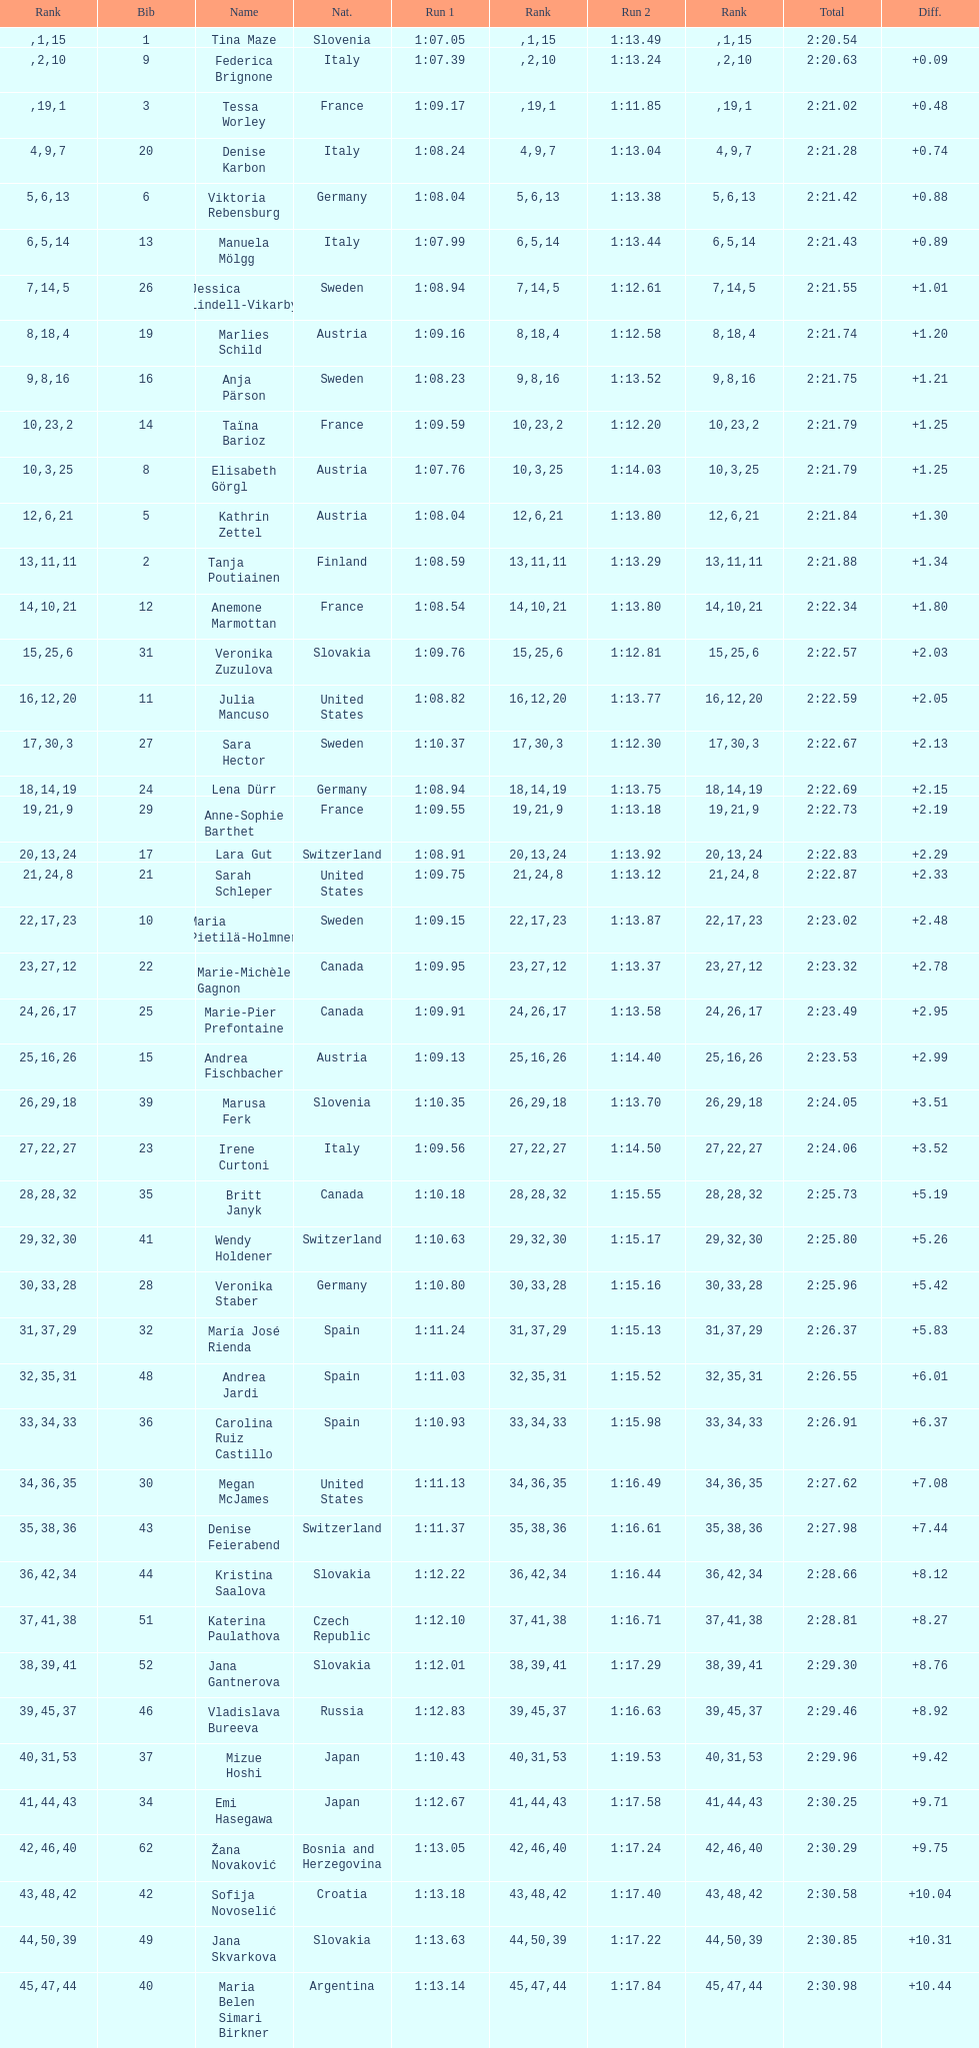Which country is positioned last in the ranking? Czech Republic. Could you help me parse every detail presented in this table? {'header': ['Rank', 'Bib', 'Name', 'Nat.', 'Run 1', 'Rank', 'Run 2', 'Rank', 'Total', 'Diff.'], 'rows': [['', '1', 'Tina Maze', 'Slovenia', '1:07.05', '1', '1:13.49', '15', '2:20.54', ''], ['', '9', 'Federica Brignone', 'Italy', '1:07.39', '2', '1:13.24', '10', '2:20.63', '+0.09'], ['', '3', 'Tessa Worley', 'France', '1:09.17', '19', '1:11.85', '1', '2:21.02', '+0.48'], ['4', '20', 'Denise Karbon', 'Italy', '1:08.24', '9', '1:13.04', '7', '2:21.28', '+0.74'], ['5', '6', 'Viktoria Rebensburg', 'Germany', '1:08.04', '6', '1:13.38', '13', '2:21.42', '+0.88'], ['6', '13', 'Manuela Mölgg', 'Italy', '1:07.99', '5', '1:13.44', '14', '2:21.43', '+0.89'], ['7', '26', 'Jessica Lindell-Vikarby', 'Sweden', '1:08.94', '14', '1:12.61', '5', '2:21.55', '+1.01'], ['8', '19', 'Marlies Schild', 'Austria', '1:09.16', '18', '1:12.58', '4', '2:21.74', '+1.20'], ['9', '16', 'Anja Pärson', 'Sweden', '1:08.23', '8', '1:13.52', '16', '2:21.75', '+1.21'], ['10', '14', 'Taïna Barioz', 'France', '1:09.59', '23', '1:12.20', '2', '2:21.79', '+1.25'], ['10', '8', 'Elisabeth Görgl', 'Austria', '1:07.76', '3', '1:14.03', '25', '2:21.79', '+1.25'], ['12', '5', 'Kathrin Zettel', 'Austria', '1:08.04', '6', '1:13.80', '21', '2:21.84', '+1.30'], ['13', '2', 'Tanja Poutiainen', 'Finland', '1:08.59', '11', '1:13.29', '11', '2:21.88', '+1.34'], ['14', '12', 'Anemone Marmottan', 'France', '1:08.54', '10', '1:13.80', '21', '2:22.34', '+1.80'], ['15', '31', 'Veronika Zuzulova', 'Slovakia', '1:09.76', '25', '1:12.81', '6', '2:22.57', '+2.03'], ['16', '11', 'Julia Mancuso', 'United States', '1:08.82', '12', '1:13.77', '20', '2:22.59', '+2.05'], ['17', '27', 'Sara Hector', 'Sweden', '1:10.37', '30', '1:12.30', '3', '2:22.67', '+2.13'], ['18', '24', 'Lena Dürr', 'Germany', '1:08.94', '14', '1:13.75', '19', '2:22.69', '+2.15'], ['19', '29', 'Anne-Sophie Barthet', 'France', '1:09.55', '21', '1:13.18', '9', '2:22.73', '+2.19'], ['20', '17', 'Lara Gut', 'Switzerland', '1:08.91', '13', '1:13.92', '24', '2:22.83', '+2.29'], ['21', '21', 'Sarah Schleper', 'United States', '1:09.75', '24', '1:13.12', '8', '2:22.87', '+2.33'], ['22', '10', 'Maria Pietilä-Holmner', 'Sweden', '1:09.15', '17', '1:13.87', '23', '2:23.02', '+2.48'], ['23', '22', 'Marie-Michèle Gagnon', 'Canada', '1:09.95', '27', '1:13.37', '12', '2:23.32', '+2.78'], ['24', '25', 'Marie-Pier Prefontaine', 'Canada', '1:09.91', '26', '1:13.58', '17', '2:23.49', '+2.95'], ['25', '15', 'Andrea Fischbacher', 'Austria', '1:09.13', '16', '1:14.40', '26', '2:23.53', '+2.99'], ['26', '39', 'Marusa Ferk', 'Slovenia', '1:10.35', '29', '1:13.70', '18', '2:24.05', '+3.51'], ['27', '23', 'Irene Curtoni', 'Italy', '1:09.56', '22', '1:14.50', '27', '2:24.06', '+3.52'], ['28', '35', 'Britt Janyk', 'Canada', '1:10.18', '28', '1:15.55', '32', '2:25.73', '+5.19'], ['29', '41', 'Wendy Holdener', 'Switzerland', '1:10.63', '32', '1:15.17', '30', '2:25.80', '+5.26'], ['30', '28', 'Veronika Staber', 'Germany', '1:10.80', '33', '1:15.16', '28', '2:25.96', '+5.42'], ['31', '32', 'María José Rienda', 'Spain', '1:11.24', '37', '1:15.13', '29', '2:26.37', '+5.83'], ['32', '48', 'Andrea Jardi', 'Spain', '1:11.03', '35', '1:15.52', '31', '2:26.55', '+6.01'], ['33', '36', 'Carolina Ruiz Castillo', 'Spain', '1:10.93', '34', '1:15.98', '33', '2:26.91', '+6.37'], ['34', '30', 'Megan McJames', 'United States', '1:11.13', '36', '1:16.49', '35', '2:27.62', '+7.08'], ['35', '43', 'Denise Feierabend', 'Switzerland', '1:11.37', '38', '1:16.61', '36', '2:27.98', '+7.44'], ['36', '44', 'Kristina Saalova', 'Slovakia', '1:12.22', '42', '1:16.44', '34', '2:28.66', '+8.12'], ['37', '51', 'Katerina Paulathova', 'Czech Republic', '1:12.10', '41', '1:16.71', '38', '2:28.81', '+8.27'], ['38', '52', 'Jana Gantnerova', 'Slovakia', '1:12.01', '39', '1:17.29', '41', '2:29.30', '+8.76'], ['39', '46', 'Vladislava Bureeva', 'Russia', '1:12.83', '45', '1:16.63', '37', '2:29.46', '+8.92'], ['40', '37', 'Mizue Hoshi', 'Japan', '1:10.43', '31', '1:19.53', '53', '2:29.96', '+9.42'], ['41', '34', 'Emi Hasegawa', 'Japan', '1:12.67', '44', '1:17.58', '43', '2:30.25', '+9.71'], ['42', '62', 'Žana Novaković', 'Bosnia and Herzegovina', '1:13.05', '46', '1:17.24', '40', '2:30.29', '+9.75'], ['43', '42', 'Sofija Novoselić', 'Croatia', '1:13.18', '48', '1:17.40', '42', '2:30.58', '+10.04'], ['44', '49', 'Jana Skvarkova', 'Slovakia', '1:13.63', '50', '1:17.22', '39', '2:30.85', '+10.31'], ['45', '40', 'Maria Belen Simari Birkner', 'Argentina', '1:13.14', '47', '1:17.84', '44', '2:30.98', '+10.44'], ['46', '50', 'Moe Hanaoka', 'Japan', '1:13.20', '49', '1:18.56', '47', '2:31.76', '+11.22'], ['47', '65', 'Maria Shkanova', 'Belarus', '1:13.86', '53', '1:18.28', '45', '2:32.14', '+11.60'], ['48', '55', 'Katarzyna Karasinska', 'Poland', '1:13.92', '54', '1:18.46', '46', '2:32.38', '+11.84'], ['49', '59', 'Daniela Markova', 'Czech Republic', '1:13.78', '52', '1:18.87', '49', '2:32.65', '+12.11'], ['50', '58', 'Nevena Ignjatović', 'Serbia', '1:14.38', '58', '1:18.56', '47', '2:32.94', '+12.40'], ['51', '80', 'Maria Kirkova', 'Bulgaria', '1:13.70', '51', '1:19.56', '54', '2:33.26', '+12.72'], ['52', '77', 'Bogdana Matsotska', 'Ukraine', '1:14.21', '56', '1:19.18', '51', '2:33.39', '+12.85'], ['53', '68', 'Zsofia Doeme', 'Hungary', '1:14.57', '59', '1:18.93', '50', '2:33.50', '+12.96'], ['54', '56', 'Anna-Laura Bühler', 'Liechtenstein', '1:14.22', '57', '1:19.36', '52', '2:33.58', '+13.04'], ['55', '67', 'Martina Dubovska', 'Czech Republic', '1:14.62', '60', '1:19.95', '55', '2:34.57', '+14.03'], ['', '7', 'Kathrin Hölzl', 'Germany', '1:09.41', '20', 'DNS', '', '', ''], ['', '4', 'Maria Riesch', 'Germany', '1:07.86', '4', 'DNF', '', '', ''], ['', '38', 'Rebecca Bühler', 'Liechtenstein', '1:12.03', '40', 'DNF', '', '', ''], ['', '47', 'Vanessa Schädler', 'Liechtenstein', '1:12.47', '43', 'DNF', '', '', ''], ['', '69', 'Iris Gudmundsdottir', 'Iceland', '1:13.93', '55', 'DNF', '', '', ''], ['', '45', 'Tea Palić', 'Croatia', '1:14.73', '61', 'DNQ', '', '', ''], ['', '74', 'Macarena Simari Birkner', 'Argentina', '1:15.18', '62', 'DNQ', '', '', ''], ['', '72', 'Lavinia Chrystal', 'Australia', '1:15.35', '63', 'DNQ', '', '', ''], ['', '81', 'Lelde Gasuna', 'Latvia', '1:15.37', '64', 'DNQ', '', '', ''], ['', '64', 'Aleksandra Klus', 'Poland', '1:15.41', '65', 'DNQ', '', '', ''], ['', '78', 'Nino Tsiklauri', 'Georgia', '1:15.54', '66', 'DNQ', '', '', ''], ['', '66', 'Sarah Jarvis', 'New Zealand', '1:15.94', '67', 'DNQ', '', '', ''], ['', '61', 'Anna Berecz', 'Hungary', '1:15.95', '68', 'DNQ', '', '', ''], ['', '83', 'Sandra-Elena Narea', 'Romania', '1:16.67', '69', 'DNQ', '', '', ''], ['', '85', 'Iulia Petruta Craciun', 'Romania', '1:16.80', '70', 'DNQ', '', '', ''], ['', '82', 'Isabel van Buynder', 'Belgium', '1:17.06', '71', 'DNQ', '', '', ''], ['', '97', 'Liene Fimbauere', 'Latvia', '1:17.83', '72', 'DNQ', '', '', ''], ['', '86', 'Kristina Krone', 'Puerto Rico', '1:17.93', '73', 'DNQ', '', '', ''], ['', '88', 'Nicole Valcareggi', 'Greece', '1:18.19', '74', 'DNQ', '', '', ''], ['', '100', 'Sophie Fjellvang-Sølling', 'Denmark', '1:18.37', '75', 'DNQ', '', '', ''], ['', '95', 'Ornella Oettl Reyes', 'Peru', '1:18.61', '76', 'DNQ', '', '', ''], ['', '73', 'Xia Lina', 'China', '1:19.12', '77', 'DNQ', '', '', ''], ['', '94', 'Kseniya Grigoreva', 'Uzbekistan', '1:19.16', '78', 'DNQ', '', '', ''], ['', '87', 'Tugba Dasdemir', 'Turkey', '1:21.50', '79', 'DNQ', '', '', ''], ['', '92', 'Malene Madsen', 'Denmark', '1:22.25', '80', 'DNQ', '', '', ''], ['', '84', 'Liu Yang', 'China', '1:22.80', '81', 'DNQ', '', '', ''], ['', '91', 'Yom Hirshfeld', 'Israel', '1:22.87', '82', 'DNQ', '', '', ''], ['', '75', 'Salome Bancora', 'Argentina', '1:23.08', '83', 'DNQ', '', '', ''], ['', '93', 'Ronnie Kiek-Gedalyahu', 'Israel', '1:23.38', '84', 'DNQ', '', '', ''], ['', '96', 'Chiara Marano', 'Brazil', '1:24.16', '85', 'DNQ', '', '', ''], ['', '113', 'Anne Libak Nielsen', 'Denmark', '1:25.08', '86', 'DNQ', '', '', ''], ['', '105', 'Donata Hellner', 'Hungary', '1:26.97', '87', 'DNQ', '', '', ''], ['', '102', 'Liu Yu', 'China', '1:27.03', '88', 'DNQ', '', '', ''], ['', '109', 'Lida Zvoznikova', 'Kyrgyzstan', '1:27.17', '89', 'DNQ', '', '', ''], ['', '103', 'Szelina Hellner', 'Hungary', '1:27.27', '90', 'DNQ', '', '', ''], ['', '114', 'Irina Volkova', 'Kyrgyzstan', '1:29.73', '91', 'DNQ', '', '', ''], ['', '106', 'Svetlana Baranova', 'Uzbekistan', '1:30.62', '92', 'DNQ', '', '', ''], ['', '108', 'Tatjana Baranova', 'Uzbekistan', '1:31.81', '93', 'DNQ', '', '', ''], ['', '110', 'Fatemeh Kiadarbandsari', 'Iran', '1:32.16', '94', 'DNQ', '', '', ''], ['', '107', 'Ziba Kalhor', 'Iran', '1:32.64', '95', 'DNQ', '', '', ''], ['', '104', 'Paraskevi Mavridou', 'Greece', '1:32.83', '96', 'DNQ', '', '', ''], ['', '99', 'Marjan Kalhor', 'Iran', '1:34.94', '97', 'DNQ', '', '', ''], ['', '112', 'Mitra Kalhor', 'Iran', '1:37.93', '98', 'DNQ', '', '', ''], ['', '115', 'Laura Bauer', 'South Africa', '1:42.19', '99', 'DNQ', '', '', ''], ['', '111', 'Sarah Ekmekejian', 'Lebanon', '1:42.22', '100', 'DNQ', '', '', ''], ['', '18', 'Fabienne Suter', 'Switzerland', 'DNS', '', '', '', '', ''], ['', '98', 'Maja Klepić', 'Bosnia and Herzegovina', 'DNS', '', '', '', '', ''], ['', '33', 'Agniezska Gasienica Daniel', 'Poland', 'DNF', '', '', '', '', ''], ['', '53', 'Karolina Chrapek', 'Poland', 'DNF', '', '', '', '', ''], ['', '54', 'Mireia Gutierrez', 'Andorra', 'DNF', '', '', '', '', ''], ['', '57', 'Brittany Phelan', 'Canada', 'DNF', '', '', '', '', ''], ['', '60', 'Tereza Kmochova', 'Czech Republic', 'DNF', '', '', '', '', ''], ['', '63', 'Michelle van Herwerden', 'Netherlands', 'DNF', '', '', '', '', ''], ['', '70', 'Maya Harrisson', 'Brazil', 'DNF', '', '', '', '', ''], ['', '71', 'Elizabeth Pilat', 'Australia', 'DNF', '', '', '', '', ''], ['', '76', 'Katrin Kristjansdottir', 'Iceland', 'DNF', '', '', '', '', ''], ['', '79', 'Julietta Quiroga', 'Argentina', 'DNF', '', '', '', '', ''], ['', '89', 'Evija Benhena', 'Latvia', 'DNF', '', '', '', '', ''], ['', '90', 'Qin Xiyue', 'China', 'DNF', '', '', '', '', ''], ['', '101', 'Sophia Ralli', 'Greece', 'DNF', '', '', '', '', ''], ['', '116', 'Siranush Maghakyan', 'Armenia', 'DNF', '', '', '', '', '']]} 